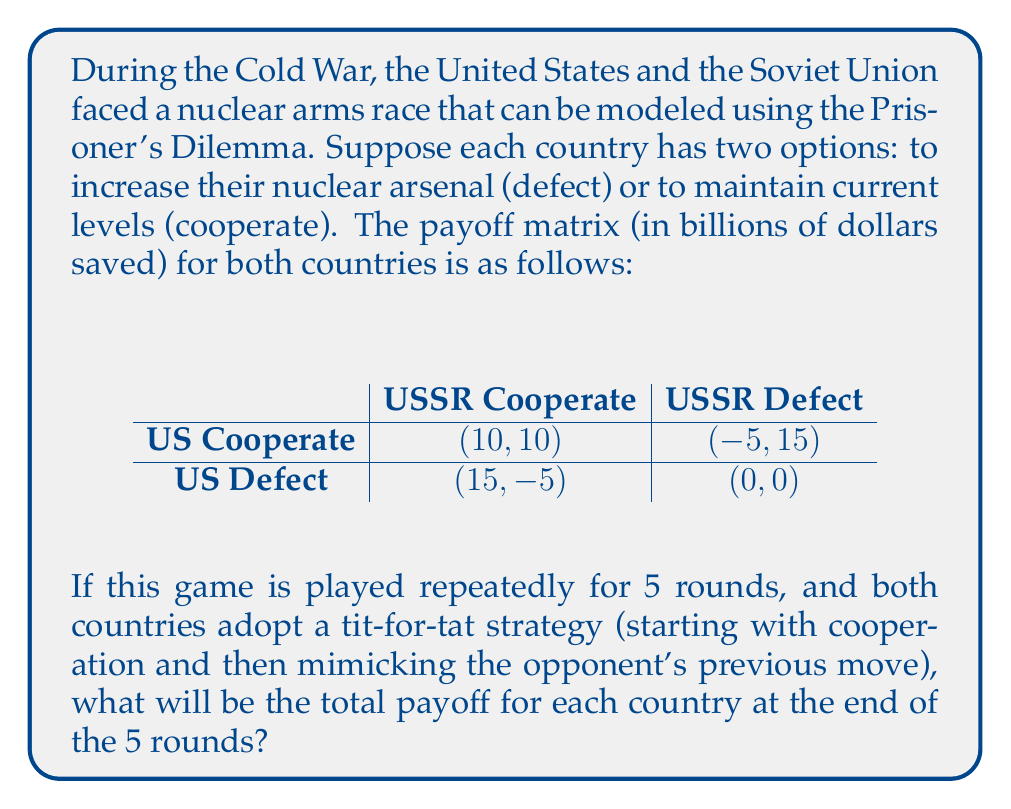Provide a solution to this math problem. To solve this problem, we need to analyze the game round by round, considering the tit-for-tat strategy:

1. In the first round, both countries cooperate:
   US payoff: $10, USSR payoff: $10

2. In the second round, both countries still cooperate (mimicking the previous move):
   US payoff: $10, USSR payoff: $10

3. This continues for all 5 rounds, as neither country has a reason to defect:
   Round 3: US payoff: $10, USSR payoff: $10
   Round 4: US payoff: $10, USSR payoff: $10
   Round 5: US payoff: $10, USSR payoff: $10

To calculate the total payoff, we sum up the payoffs from all 5 rounds:

For each country: $10 + 10 + 10 + 10 + 10 = 50$ billion dollars saved

Therefore, the total payoff for each country at the end of the 5 rounds is $50 billion.

This outcome demonstrates how the repeated Prisoner's Dilemma with a tit-for-tat strategy can lead to mutual cooperation, even in the context of Cold War tensions. It illustrates the potential for diplomatic strategies that encourage reciprocal cooperation to yield better outcomes for both parties in the long run.
Answer: $50 billion for each country 